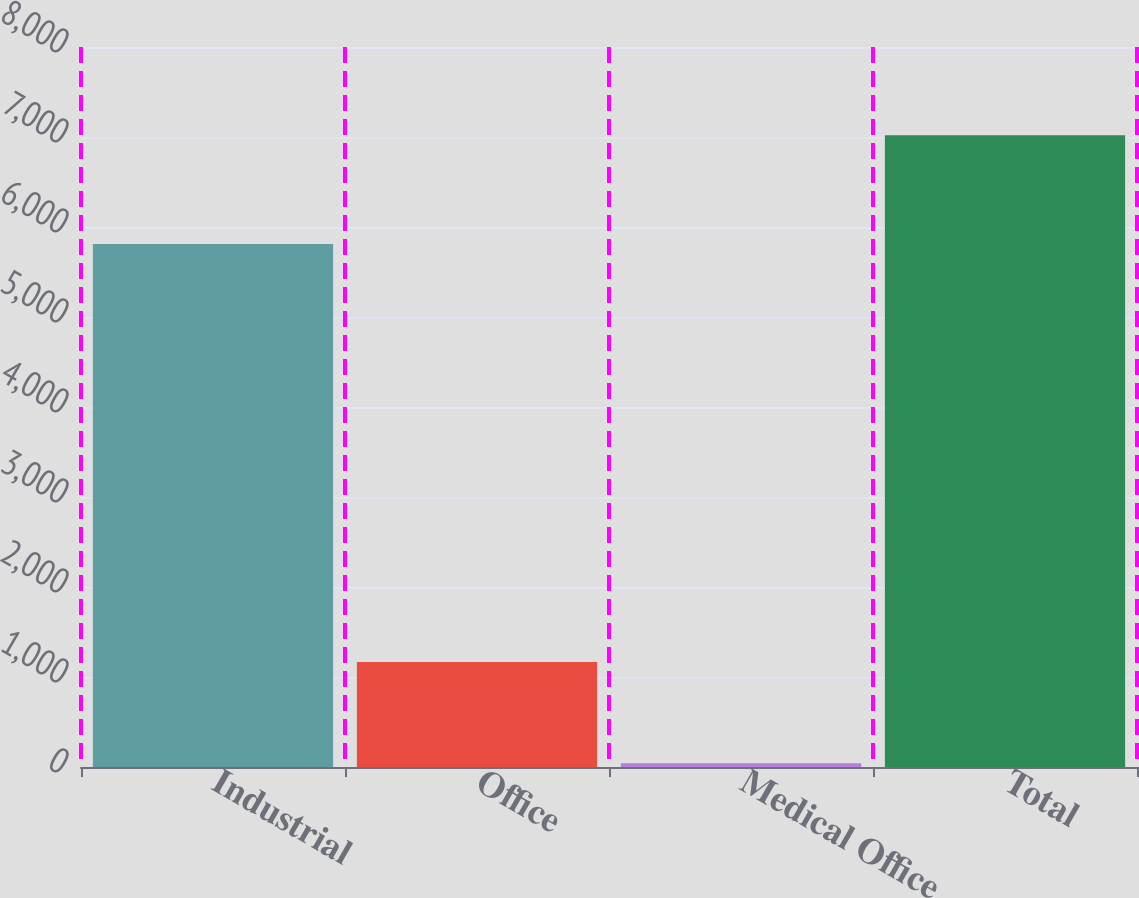Convert chart. <chart><loc_0><loc_0><loc_500><loc_500><bar_chart><fcel>Industrial<fcel>Office<fcel>Medical Office<fcel>Total<nl><fcel>5811<fcel>1167<fcel>41<fcel>7019<nl></chart> 